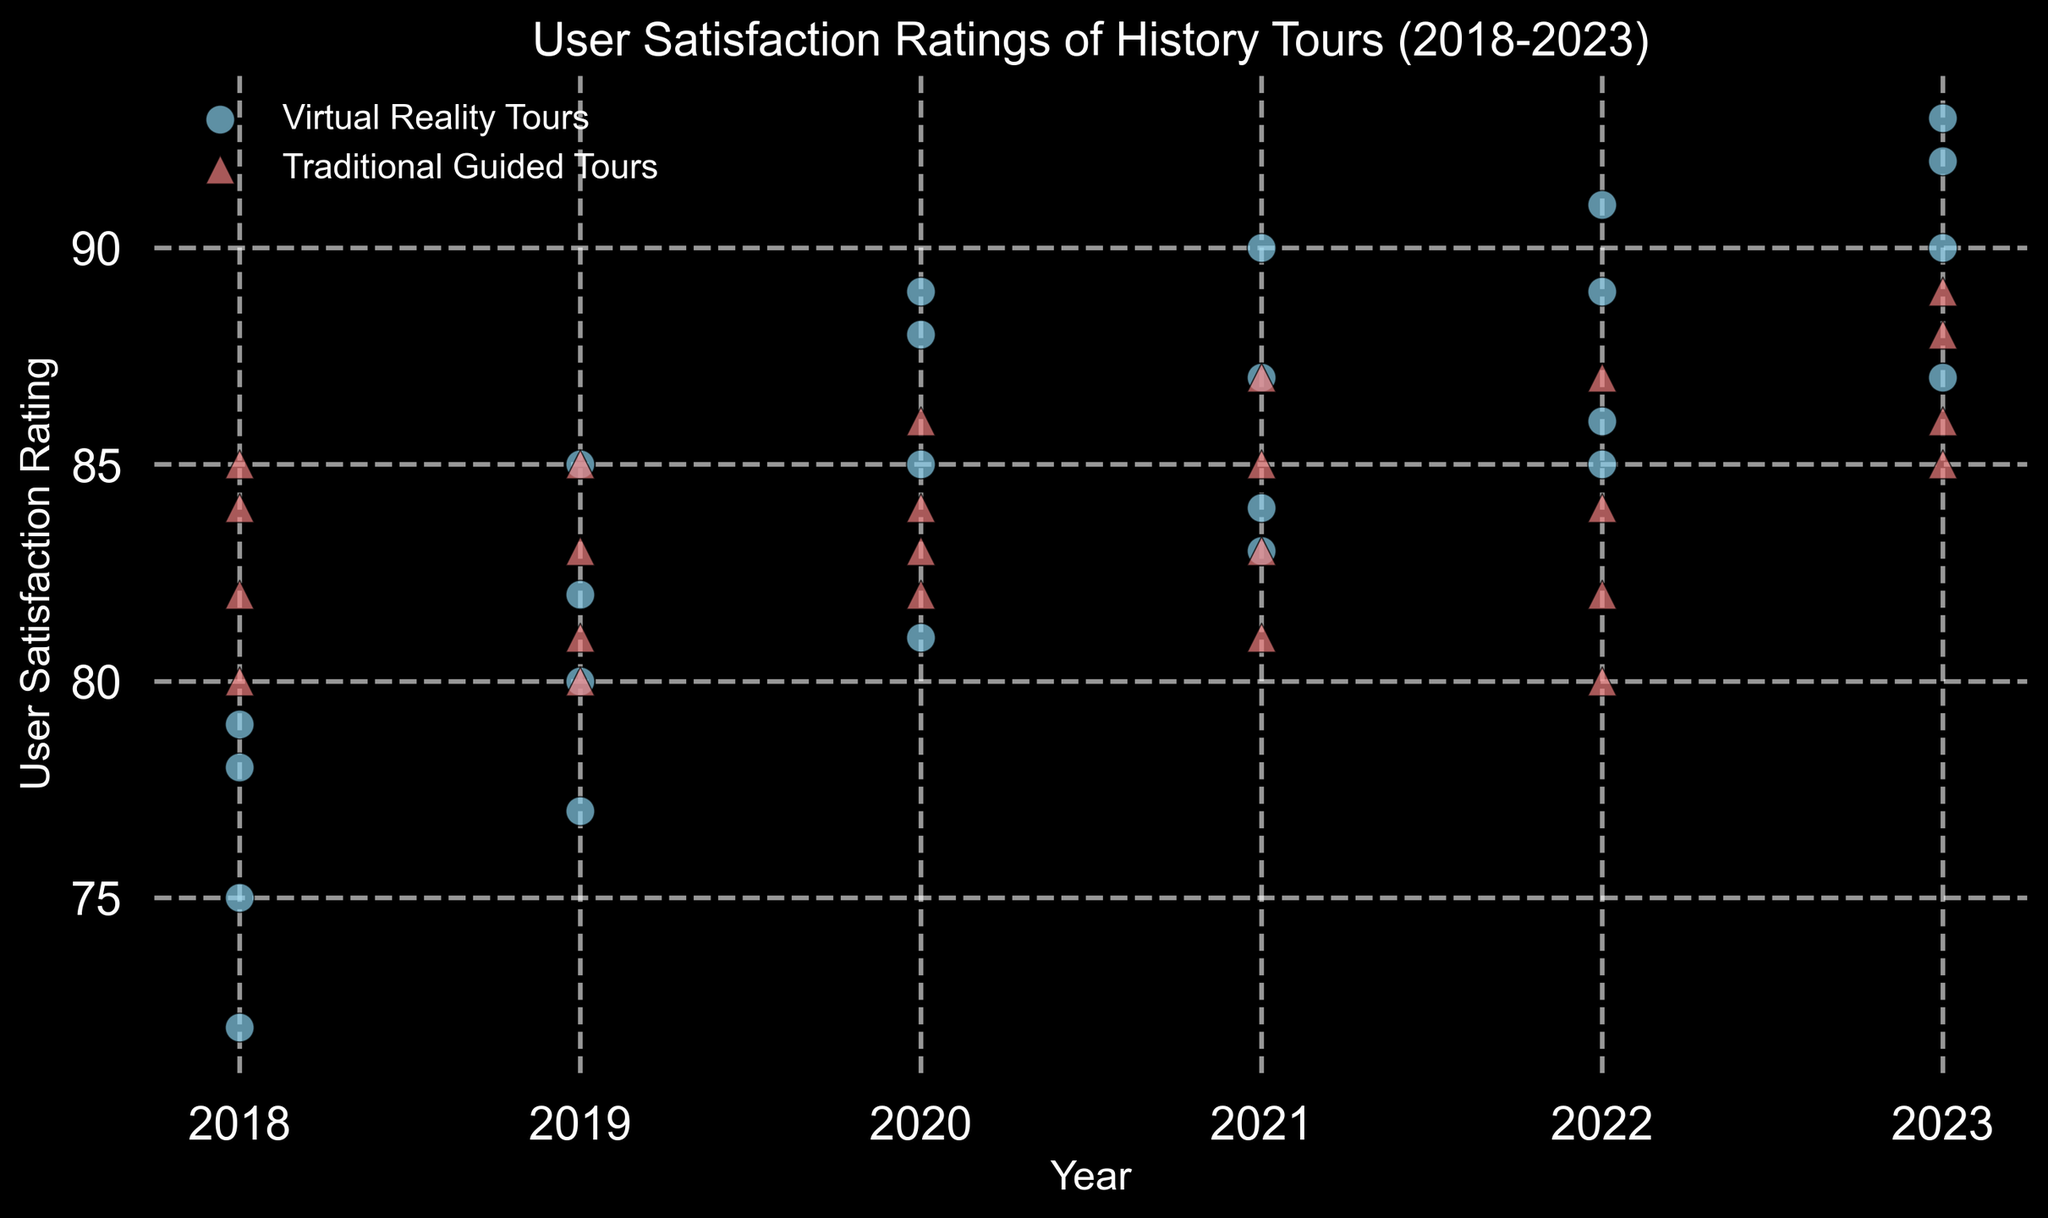What's the trend in user satisfaction ratings for Virtual Reality Tours from 2018 to 2023? The ratings for Virtual Reality Tours start in 2018 with values around 72-79. Then, they gradually increase through the years: 80-85 in 2019, 81-89 in 2020, 83-90 in 2021, 85-91 in 2022, and reach up to 87-93 in 2023. The overall trend shows an upward trajectory.
Answer: Increasing Compare the average user satisfaction ratings of Virtual Reality Tours and Traditional Guided Tours in 2023. In 2023, the ratings for Virtual Reality Tours are 92, 87, 90, and 93. Adding these: 92 + 87 + 90 + 93 = 362; the average is 362 / 4 = 90.5. For Traditional Guided Tours, the ratings are 88, 85, 86, and 89. Adding these: 88 + 85 + 86 + 89 = 348; the average is 348 / 4 = 87. Therefore, Virtual Reality Tours have a higher average rating in 2023.
Answer: Virtual Reality Tours Which year shows the highest user satisfaction rating for Traditional Guided Tours? Looking at the data, the highest rating for Traditional Guided Tours is 89, which occurs in 2023.
Answer: 2023 How do the satisfaction ratings in 2018 for Virtual Reality Tours compare to those in 2023? In 2018, the ratings for Virtual Reality Tours range from 72 to 79, while in 2023, they range from 87 to 93. Comparing these ranges, the ratings in 2023 are significantly higher than those in 2018.
Answer: 2023 higher What is the average user satisfaction rating for each type of tour in the year 2020? For Virtual Reality Tours, the ratings in 2020 are 88, 81, 89, and 85. Adding these: 88 + 81 + 89 + 85 = 343; the average is 343 / 4 = 85.75. For Traditional Guided Tours, the ratings are 84, 82, 86, and 83. Adding these: 84 + 82 + 86 + 83 = 335; the average is 335 / 4 = 83.75.
Answer: Virtual: 85.75, Traditional: 83.75 Which type of tour shows a greater improvement in average user satisfaction from 2018 to 2022? The average rating for Virtual Reality Tours in 2018 is calculated as (75 + 78 + 72 + 79) / 4 = 76. The average in 2022 is (86 + 91 + 85 + 89) / 4 = 87.75, showing an improvement of 11.75. For Traditional Guided Tours, the average in 2018 is (82 + 80 + 85 + 84) / 4 = 82.75, and in 2022 it is (80 + 87 + 82 + 84) / 4 = 83.25, showing an improvement of 0.5.
Answer: Virtual Reality Tours Is there any year where Traditional Guided Tours have consistently higher ratings than Virtual Reality Tours? In 2018, the ratings for Traditional Guided Tours consistently exceed those of Virtual Reality Tours for each pair of data points given.
Answer: 2018 Compare the visual markers used for Virtual Reality Tours and Traditional Guided Tours in the plot. The scatter plot uses circles ("o" marker) with sky blue color for Virtual Reality Tours and triangles ("^" marker) with light coral color for Traditional Guided Tours. Both have black edges.
Answer: Circle for VR, Triangle for Traditional Which year demonstrates the closest parity in user satisfaction ratings between the two tour types? In 2020, the satisfaction ratings for Virtual Reality Tours (88, 81, 89, 85) and Traditional Guided Tours (84, 82, 86, 83) are relatively close to each other, showing the least disparity.
Answer: 2020 